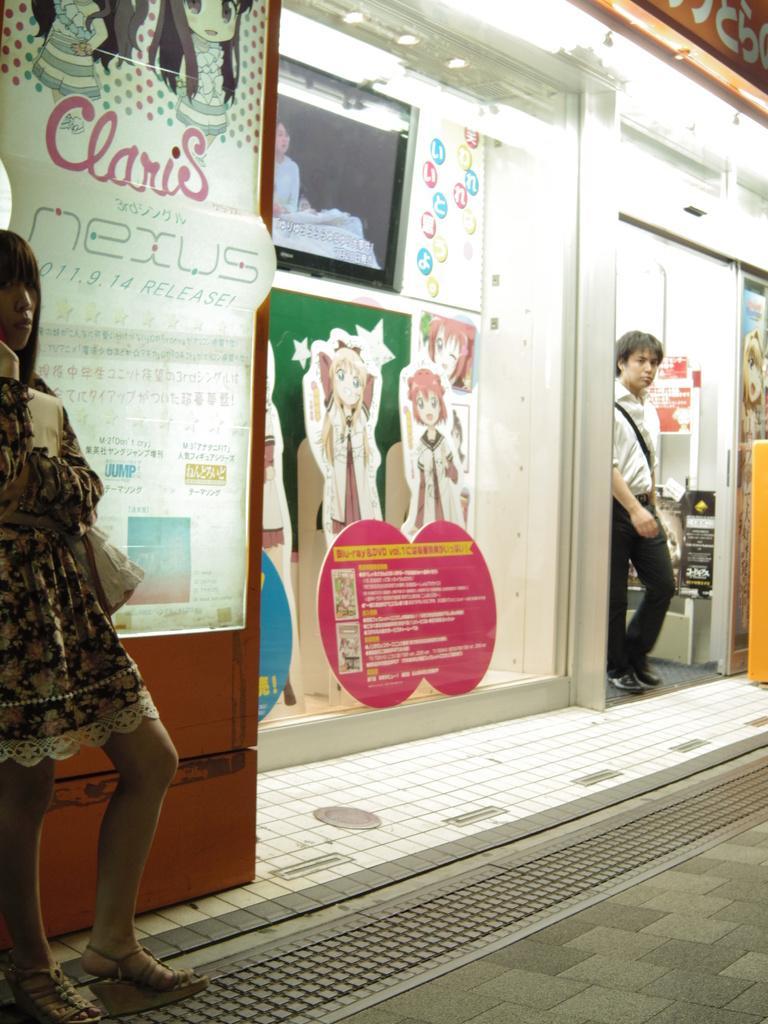Describe this image in one or two sentences. In this image we can see people. In the background there is a store and we can see boards placed on the glass. At the bottom there is a road. On the right there is a door. 